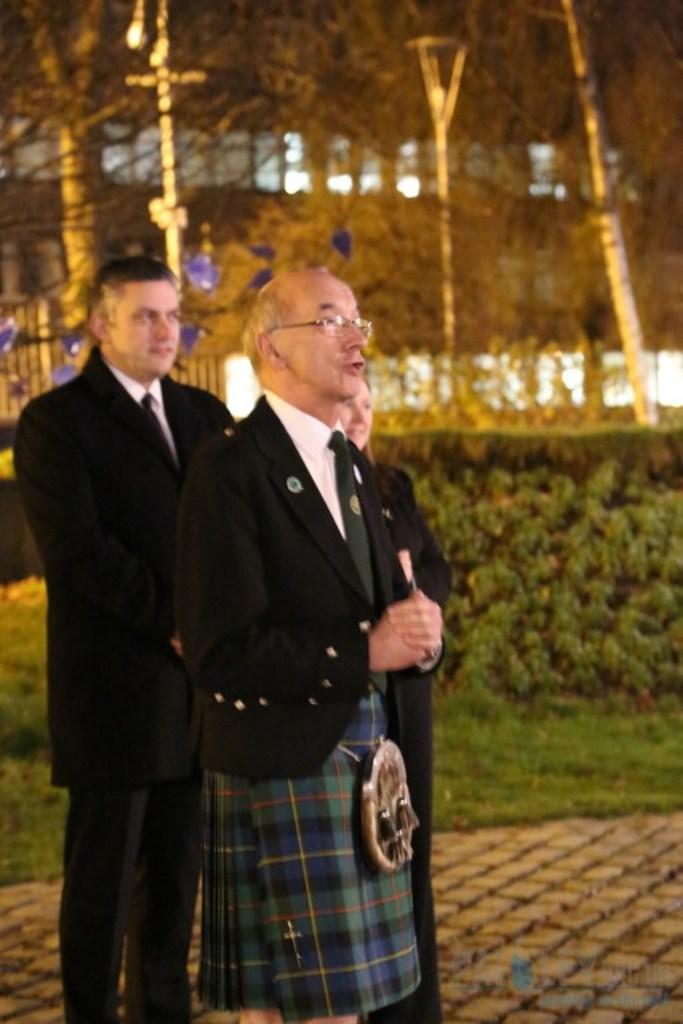Could you give a brief overview of what you see in this image? In this image there are three persons standing , and in the background there is grass, plants,trees, building. 